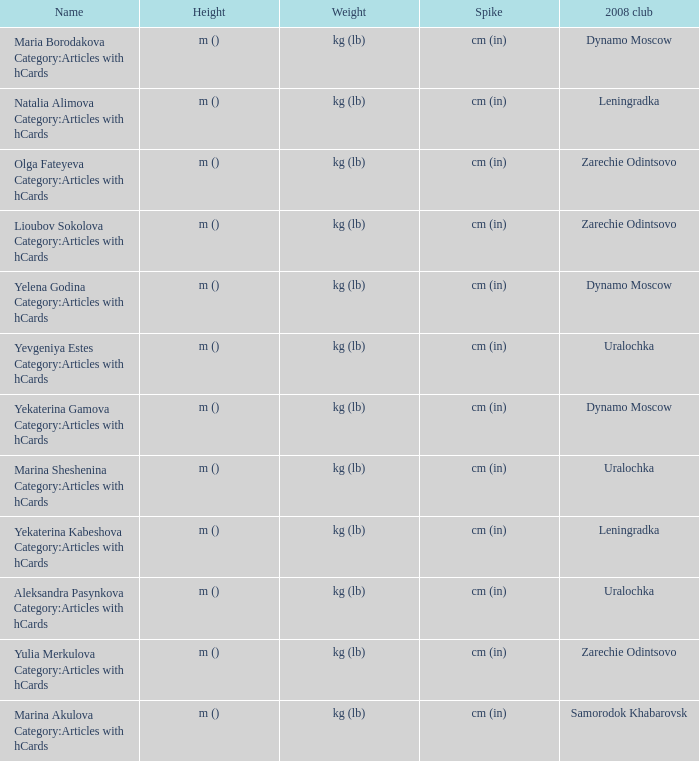Could you parse the entire table? {'header': ['Name', 'Height', 'Weight', 'Spike', '2008 club'], 'rows': [['Maria Borodakova Category:Articles with hCards', 'm ()', 'kg (lb)', 'cm (in)', 'Dynamo Moscow'], ['Natalia Alimova Category:Articles with hCards', 'm ()', 'kg (lb)', 'cm (in)', 'Leningradka'], ['Olga Fateyeva Category:Articles with hCards', 'm ()', 'kg (lb)', 'cm (in)', 'Zarechie Odintsovo'], ['Lioubov Sokolova Category:Articles with hCards', 'm ()', 'kg (lb)', 'cm (in)', 'Zarechie Odintsovo'], ['Yelena Godina Category:Articles with hCards', 'm ()', 'kg (lb)', 'cm (in)', 'Dynamo Moscow'], ['Yevgeniya Estes Category:Articles with hCards', 'm ()', 'kg (lb)', 'cm (in)', 'Uralochka'], ['Yekaterina Gamova Category:Articles with hCards', 'm ()', 'kg (lb)', 'cm (in)', 'Dynamo Moscow'], ['Marina Sheshenina Category:Articles with hCards', 'm ()', 'kg (lb)', 'cm (in)', 'Uralochka'], ['Yekaterina Kabeshova Category:Articles with hCards', 'm ()', 'kg (lb)', 'cm (in)', 'Leningradka'], ['Aleksandra Pasynkova Category:Articles with hCards', 'm ()', 'kg (lb)', 'cm (in)', 'Uralochka'], ['Yulia Merkulova Category:Articles with hCards', 'm ()', 'kg (lb)', 'cm (in)', 'Zarechie Odintsovo'], ['Marina Akulova Category:Articles with hCards', 'm ()', 'kg (lb)', 'cm (in)', 'Samorodok Khabarovsk']]} What is the name when the 2008 club is uralochka? Yevgeniya Estes Category:Articles with hCards, Marina Sheshenina Category:Articles with hCards, Aleksandra Pasynkova Category:Articles with hCards. 